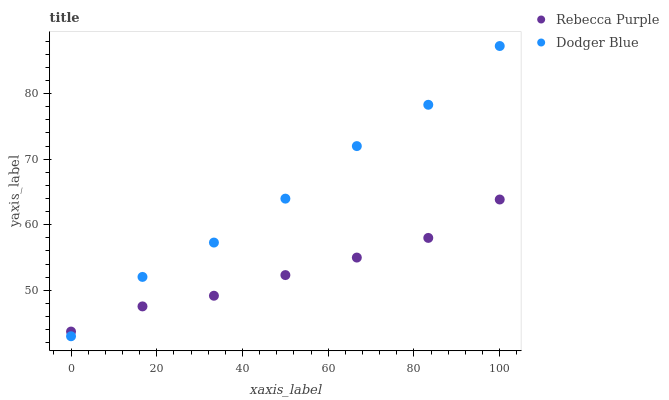Does Rebecca Purple have the minimum area under the curve?
Answer yes or no. Yes. Does Dodger Blue have the maximum area under the curve?
Answer yes or no. Yes. Does Rebecca Purple have the maximum area under the curve?
Answer yes or no. No. Is Rebecca Purple the smoothest?
Answer yes or no. Yes. Is Dodger Blue the roughest?
Answer yes or no. Yes. Is Rebecca Purple the roughest?
Answer yes or no. No. Does Dodger Blue have the lowest value?
Answer yes or no. Yes. Does Rebecca Purple have the lowest value?
Answer yes or no. No. Does Dodger Blue have the highest value?
Answer yes or no. Yes. Does Rebecca Purple have the highest value?
Answer yes or no. No. Does Rebecca Purple intersect Dodger Blue?
Answer yes or no. Yes. Is Rebecca Purple less than Dodger Blue?
Answer yes or no. No. Is Rebecca Purple greater than Dodger Blue?
Answer yes or no. No. 